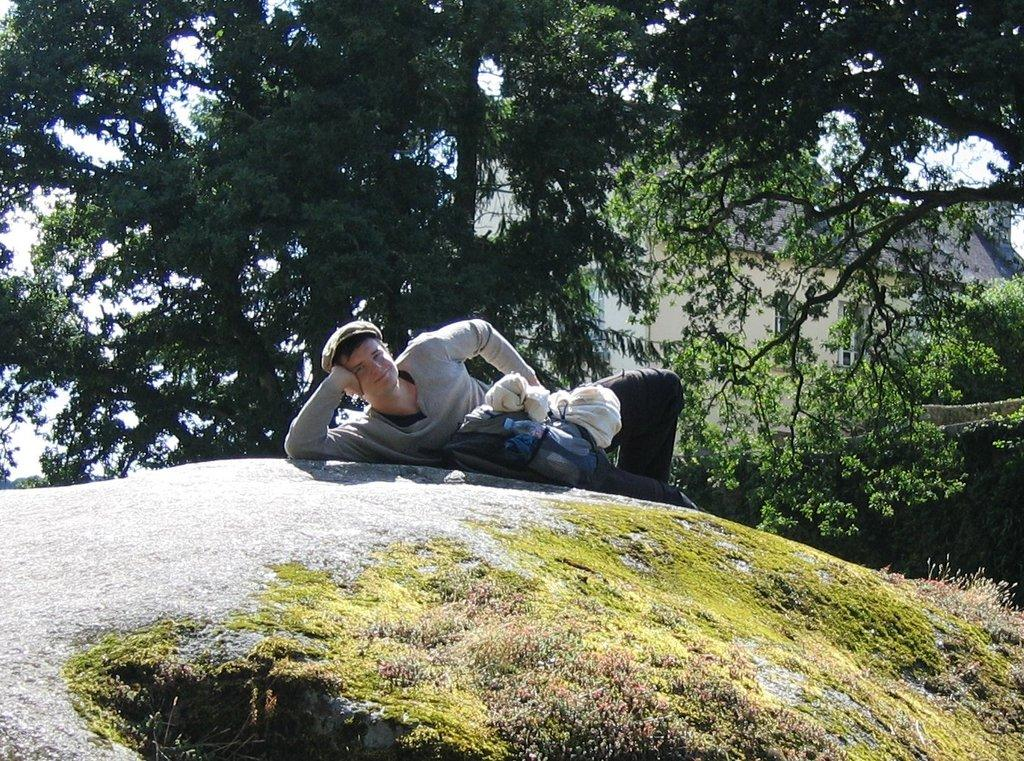What is the man in the image doing? The man is lying on a rock in the image. What can be seen in the background of the image? There are trees, buildings, and the sky visible in the background of the image. What language is the man speaking to his uncle in the image? There is no uncle present in the image, and the man is not speaking. 